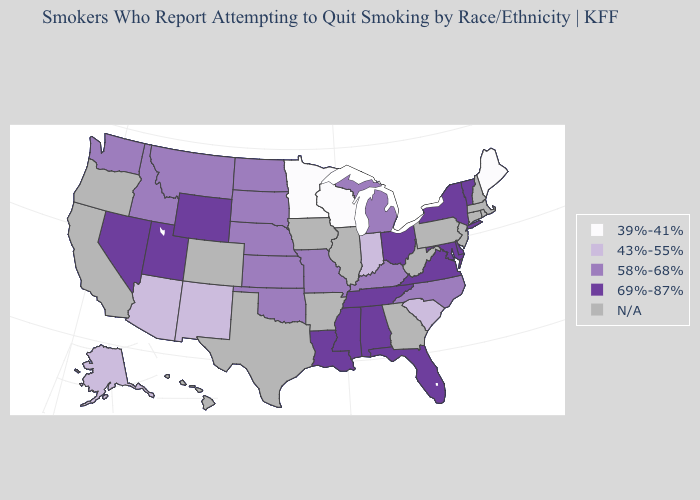Name the states that have a value in the range N/A?
Keep it brief. Arkansas, California, Colorado, Connecticut, Georgia, Hawaii, Illinois, Iowa, Massachusetts, New Hampshire, New Jersey, Oregon, Pennsylvania, Rhode Island, Texas, West Virginia. Which states hav the highest value in the South?
Give a very brief answer. Alabama, Delaware, Florida, Louisiana, Maryland, Mississippi, Tennessee, Virginia. Does the first symbol in the legend represent the smallest category?
Answer briefly. Yes. Which states hav the highest value in the Northeast?
Answer briefly. New York, Vermont. Does the first symbol in the legend represent the smallest category?
Quick response, please. Yes. Does Tennessee have the lowest value in the South?
Write a very short answer. No. What is the value of Iowa?
Answer briefly. N/A. What is the lowest value in the USA?
Quick response, please. 39%-41%. What is the value of Delaware?
Short answer required. 69%-87%. Does the first symbol in the legend represent the smallest category?
Answer briefly. Yes. Does the map have missing data?
Give a very brief answer. Yes. What is the value of New Hampshire?
Quick response, please. N/A. Which states have the lowest value in the West?
Short answer required. Alaska, Arizona, New Mexico. 